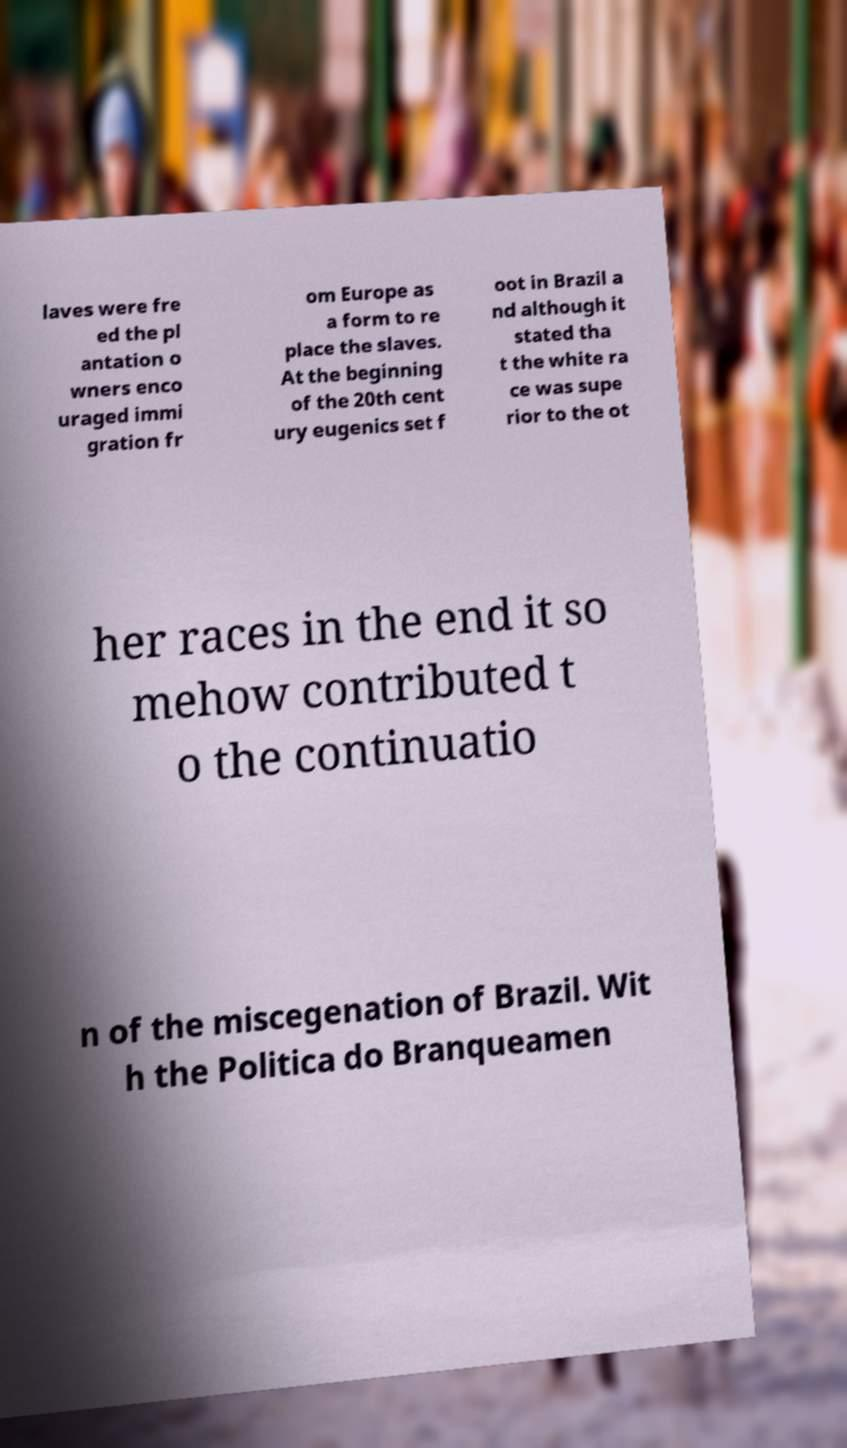I need the written content from this picture converted into text. Can you do that? laves were fre ed the pl antation o wners enco uraged immi gration fr om Europe as a form to re place the slaves. At the beginning of the 20th cent ury eugenics set f oot in Brazil a nd although it stated tha t the white ra ce was supe rior to the ot her races in the end it so mehow contributed t o the continuatio n of the miscegenation of Brazil. Wit h the Politica do Branqueamen 